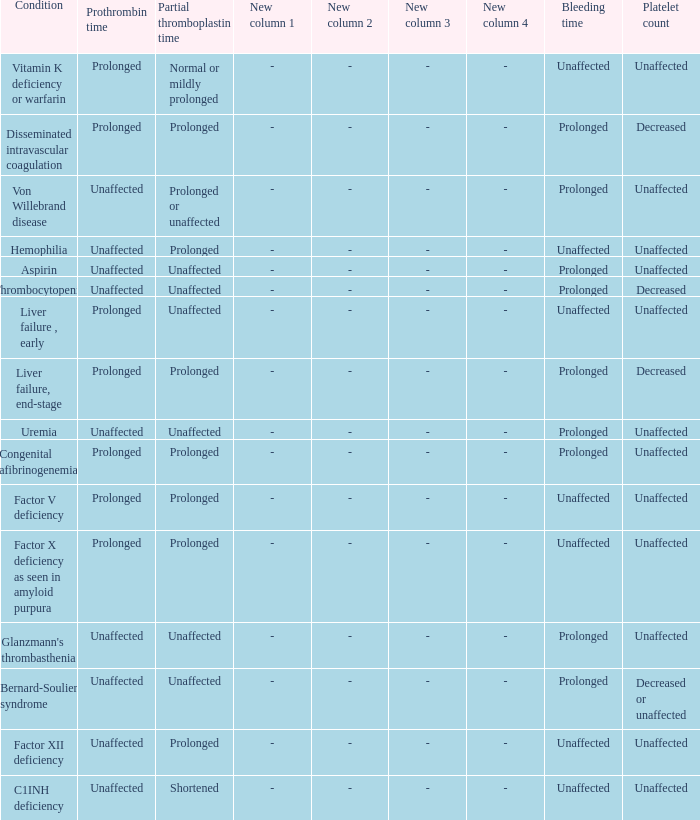What disease presents with unaffected bleeding duration, elongated partial thromboplastin time, and consistent prothrombin time? Hemophilia, Factor XII deficiency. I'm looking to parse the entire table for insights. Could you assist me with that? {'header': ['Condition', 'Prothrombin time', 'Partial thromboplastin time', 'New column 1', 'New column 2', 'New column 3', 'New column 4', 'Bleeding time', 'Platelet count'], 'rows': [['Vitamin K deficiency or warfarin', 'Prolonged', 'Normal or mildly prolonged', '-', '-', '-', '-', 'Unaffected', 'Unaffected'], ['Disseminated intravascular coagulation', 'Prolonged', 'Prolonged', '-', '-', '-', '-', 'Prolonged', 'Decreased'], ['Von Willebrand disease', 'Unaffected', 'Prolonged or unaffected', '-', '-', '-', '-', 'Prolonged', 'Unaffected'], ['Hemophilia', 'Unaffected', 'Prolonged', '-', '-', '-', '-', 'Unaffected', 'Unaffected'], ['Aspirin', 'Unaffected', 'Unaffected', '-', '-', '-', '-', 'Prolonged', 'Unaffected'], ['Thrombocytopenia', 'Unaffected', 'Unaffected', '-', '-', '-', '-', 'Prolonged', 'Decreased'], ['Liver failure , early', 'Prolonged', 'Unaffected', '-', '-', '-', '-', 'Unaffected', 'Unaffected'], ['Liver failure, end-stage', 'Prolonged', 'Prolonged', '-', '-', '-', '-', 'Prolonged', 'Decreased'], ['Uremia', 'Unaffected', 'Unaffected', '-', '-', '-', '-', 'Prolonged', 'Unaffected'], ['Congenital afibrinogenemia', 'Prolonged', 'Prolonged', '-', '-', '-', '-', 'Prolonged', 'Unaffected'], ['Factor V deficiency', 'Prolonged', 'Prolonged', '-', '-', '-', '-', 'Unaffected', 'Unaffected'], ['Factor X deficiency as seen in amyloid purpura', 'Prolonged', 'Prolonged', '-', '-', '-', '-', 'Unaffected', 'Unaffected'], ["Glanzmann's thrombasthenia", 'Unaffected', 'Unaffected', '-', '-', '-', '-', 'Prolonged', 'Unaffected'], ['Bernard-Soulier syndrome', 'Unaffected', 'Unaffected', '-', '-', '-', '-', 'Prolonged', 'Decreased or unaffected'], ['Factor XII deficiency', 'Unaffected', 'Prolonged', '-', '-', '-', '-', 'Unaffected', 'Unaffected'], ['C1INH deficiency', 'Unaffected', 'Shortened', '-', '-', '-', '-', 'Unaffected', 'Unaffected']]} 